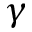Convert formula to latex. <formula><loc_0><loc_0><loc_500><loc_500>\gamma</formula> 